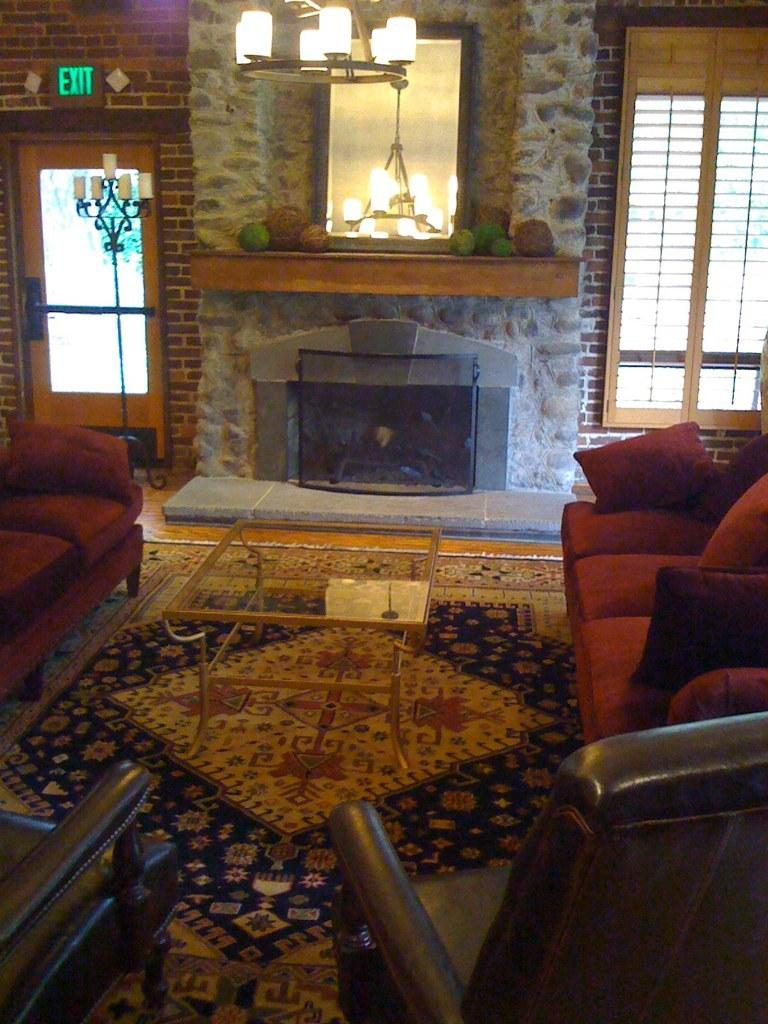What type of furniture is present in the image? There is a sofa set and 2 chairs in the image. What is the purpose of the table in the image? The table is likely used for placing items or serving food. What can be seen in the background of the image? There is a door, lights, a mirror, and a wall in the background of the image. What type of pet can be seen playing with a foot in the image? There is no pet or foot present in the image. What observation can be made about the mirror in the image? The mirror is reflecting the background elements, such as the door, lights, and wall. 